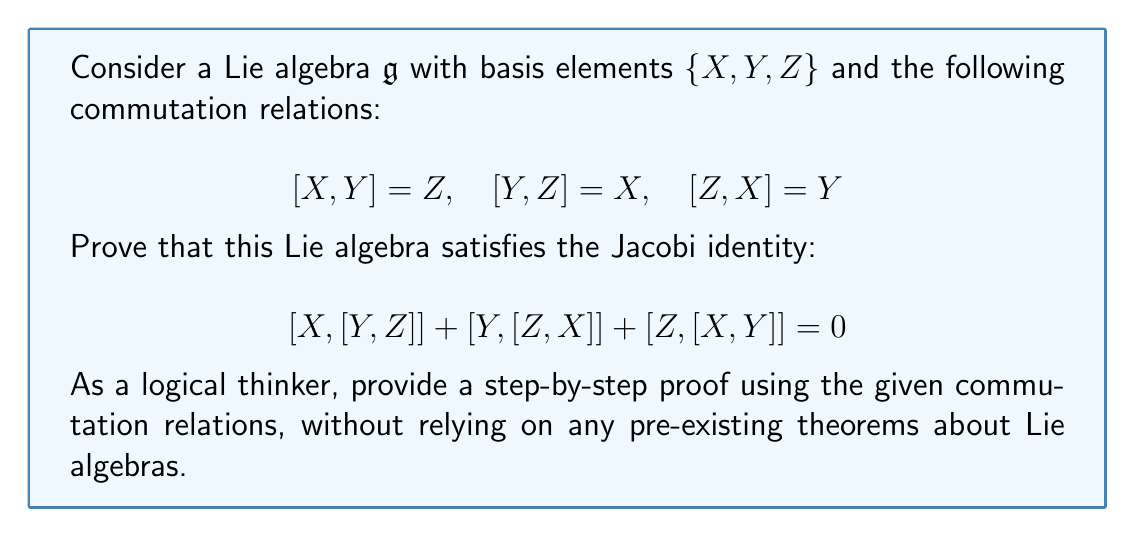Provide a solution to this math problem. To prove the Jacobi identity for this Lie algebra, we'll follow these steps:

1) First, let's evaluate each term in the Jacobi identity separately:

   a) $[X, [Y, Z]]$:
      We know $[Y, Z] = X$, so this becomes $[X, X] = 0$ (since the Lie bracket is antisymmetric)

   b) $[Y, [Z, X]]$:
      We know $[Z, X] = Y$, so this becomes $[Y, Y] = 0$

   c) $[Z, [X, Y]]$:
      We know $[X, Y] = Z$, so this becomes $[Z, Z] = 0$

2) Now, let's substitute these results into the Jacobi identity:

   $$[X, [Y, Z]] + [Y, [Z, X]] + [Z, [X, Y]] = 0 + 0 + 0 = 0$$

3) This proves that the Jacobi identity holds for this Lie algebra.

To further verify this result:

4) We can also expand the Jacobi identity using the given commutation relations:

   $$[X, [Y, Z]] + [Y, [Z, X]] + [Z, [X, Y]]$$
   $$= [X, X] + [Y, Y] + [Z, Z]$$

5) Since the Lie bracket is antisymmetric, $[A, A] = 0$ for any element $A$ in the Lie algebra. Therefore, each term in this sum is zero, confirming our initial result.

This proof demonstrates that the given Lie algebra satisfies the Jacobi identity without relying on any pre-existing theorems, using only the provided commutation relations and the basic properties of Lie brackets (antisymmetry and bilinearity).
Answer: The Jacobi identity is satisfied for the given Lie algebra. Mathematically:

$$[X, [Y, Z]] + [Y, [Z, X]] + [Z, [X, Y]] = 0 + 0 + 0 = 0$$ 